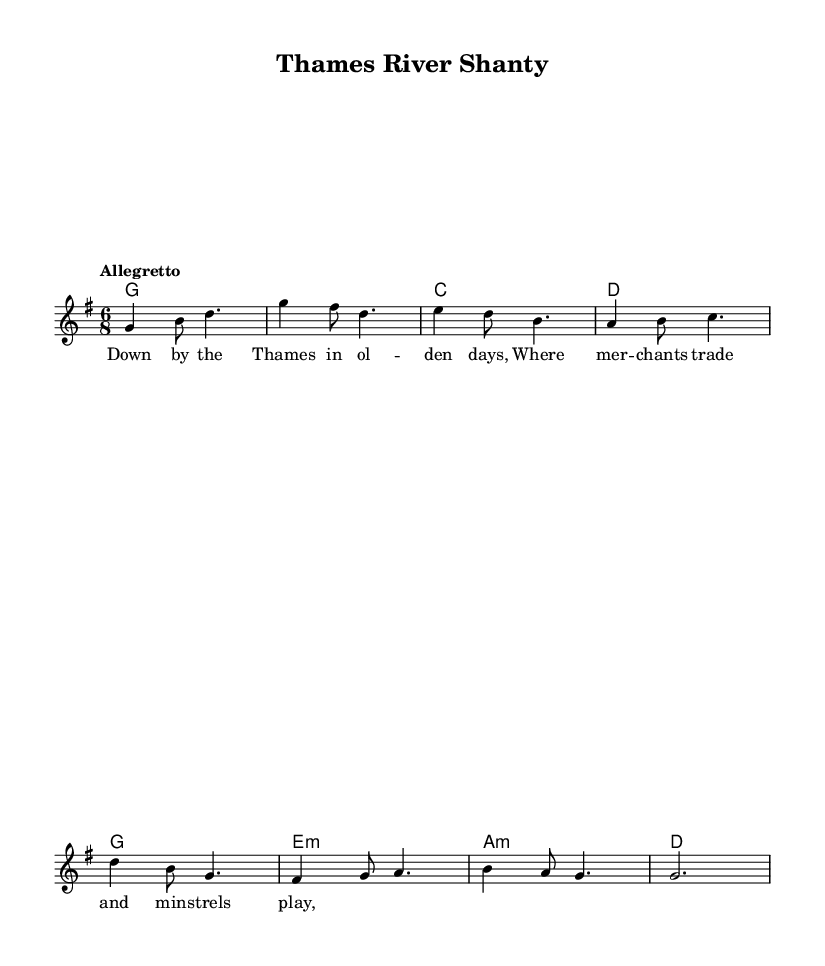What is the key signature of this music? The key signature is denoted at the beginning of the score, which is G major and has one sharp (F#) in its key signature.
Answer: G major What is the time signature of this music? The time signature, indicated at the beginning of the score as 6/8, shows that there are six eighth notes per measure, defining the rhythmic structure of the piece.
Answer: 6/8 What is the tempo marking for this piece? The tempo marking is located within the global music settings, which states "Allegretto," indicating a moderately fast pace for the performance of the piece.
Answer: Allegretto How many measures are in the melody section? By counting the distinct segments of the melody represented in the notation, we can see that it consists of a total of eight measures.
Answer: Eight What is the primary chord progression used in the harmonies? The harmonies show a sequence of chords represented with names like G, C, D, and variations of E minor and A minor, emphasizing a common folk progression centered around G major.
Answer: G, C, D What is the lyrical theme presented in the first verse? The lyrics indicate a scene set "Down by the Thames," reflecting on merchants and minstrels, which suggests the social and cultural life near the river during medieval times.
Answer: Thames River life What vocal range is suggested by the notes in the melody? Observing the range of notes, the melody covers an octave primarily starting from G and peaks around D, suggesting a typical range for folk melodies often sung by a solo or small group.
Answer: One octave 